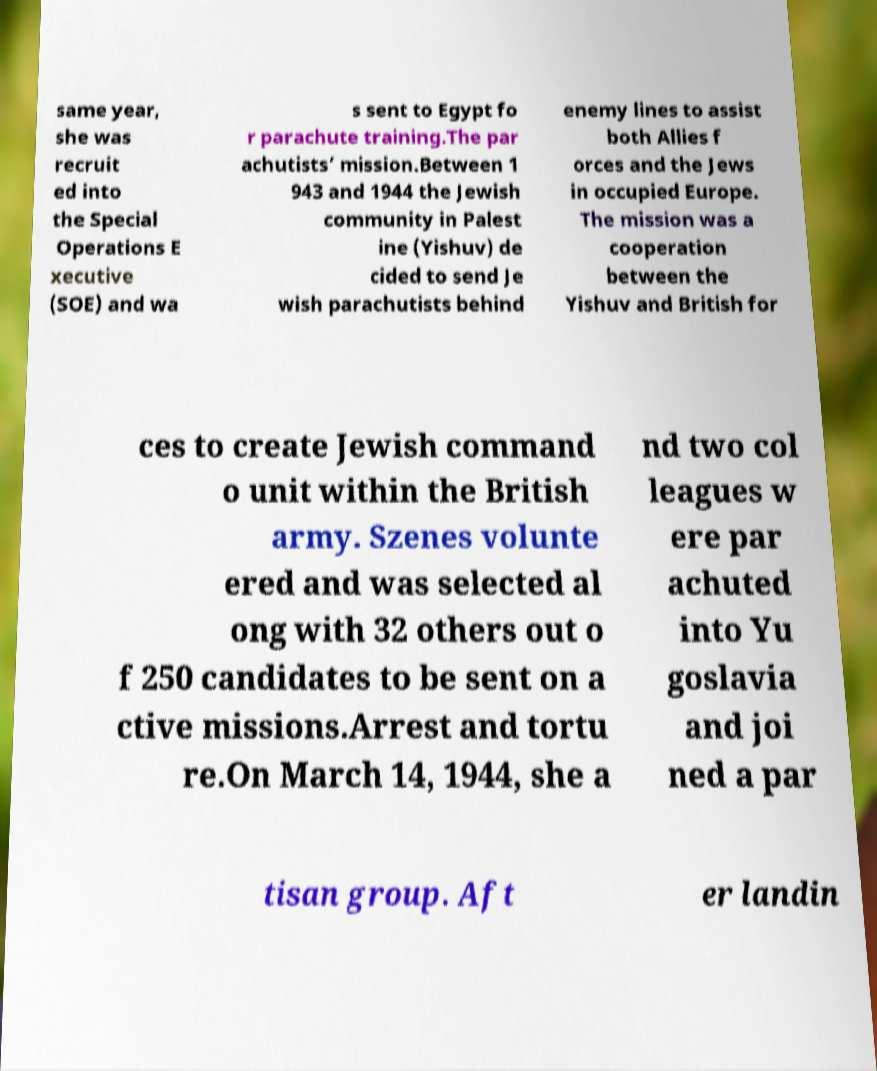Could you extract and type out the text from this image? same year, she was recruit ed into the Special Operations E xecutive (SOE) and wa s sent to Egypt fo r parachute training.The par achutists’ mission.Between 1 943 and 1944 the Jewish community in Palest ine (Yishuv) de cided to send Je wish parachutists behind enemy lines to assist both Allies f orces and the Jews in occupied Europe. The mission was a cooperation between the Yishuv and British for ces to create Jewish command o unit within the British army. Szenes volunte ered and was selected al ong with 32 others out o f 250 candidates to be sent on a ctive missions.Arrest and tortu re.On March 14, 1944, she a nd two col leagues w ere par achuted into Yu goslavia and joi ned a par tisan group. Aft er landin 